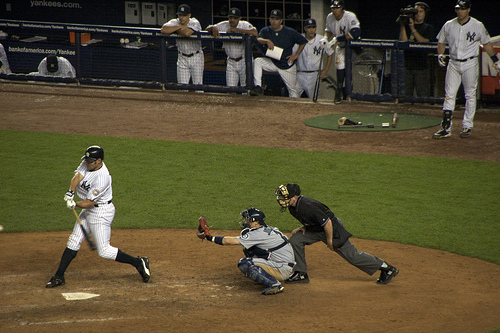<image>What number is the shirt on the man on deck? It is ambiguous what number is on the shirt of the man on the deck. What number is the shirt on the man on deck? I don't know what number the shirt on the man on deck is. It is not shown or it is unclear. 